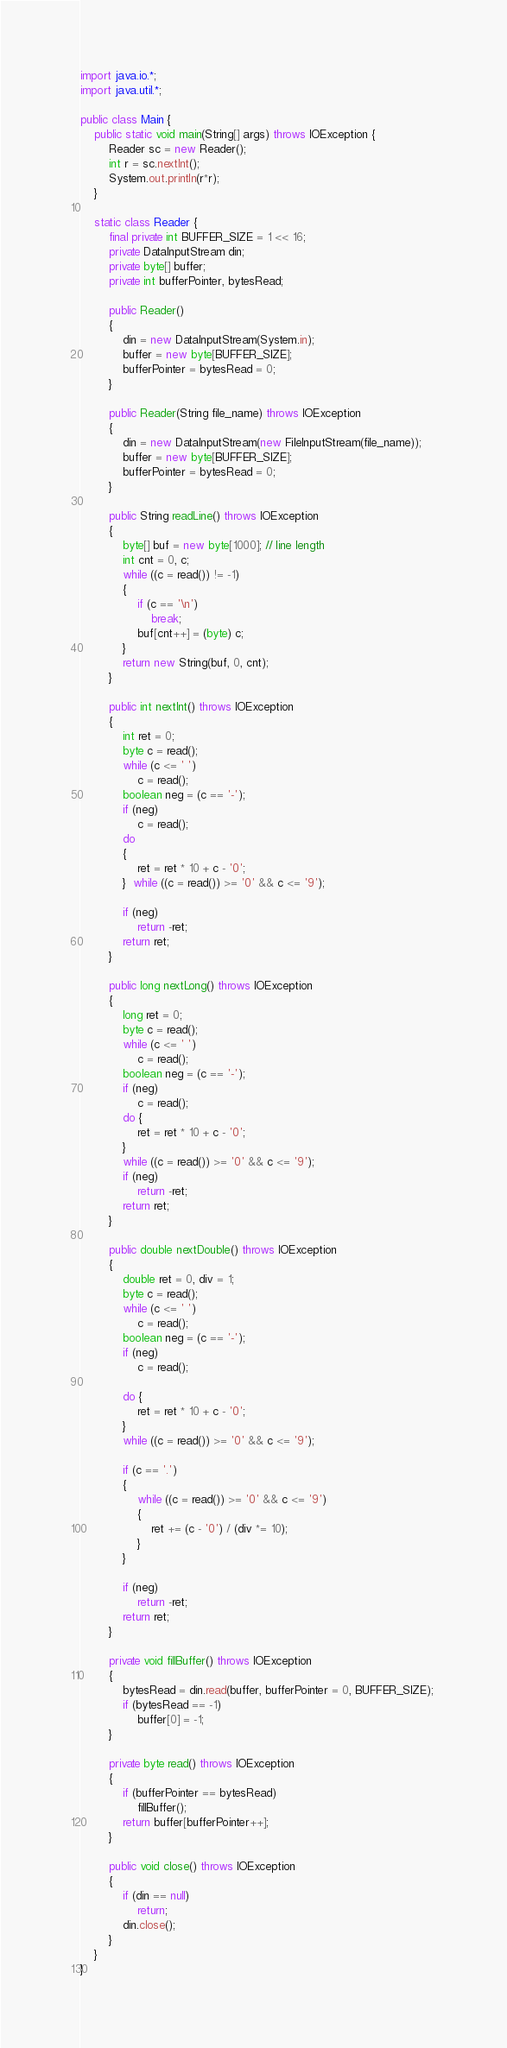Convert code to text. <code><loc_0><loc_0><loc_500><loc_500><_Java_>import java.io.*;
import java.util.*;

public class Main {
	public static void main(String[] args) throws IOException {
	    Reader sc = new Reader();
	    int r = sc.nextInt();
	   	System.out.println(r*r);
	}
	
	static class Reader { 
        final private int BUFFER_SIZE = 1 << 16; 
        private DataInputStream din; 
        private byte[] buffer; 
        private int bufferPointer, bytesRead; 
  
        public Reader() 
        { 
            din = new DataInputStream(System.in); 
            buffer = new byte[BUFFER_SIZE]; 
            bufferPointer = bytesRead = 0; 
        } 
  
        public Reader(String file_name) throws IOException 
        { 
            din = new DataInputStream(new FileInputStream(file_name)); 
            buffer = new byte[BUFFER_SIZE]; 
            bufferPointer = bytesRead = 0; 
        } 
  
        public String readLine() throws IOException 
        { 
            byte[] buf = new byte[1000]; // line length 
            int cnt = 0, c; 
            while ((c = read()) != -1) 
            { 
                if (c == '\n') 
                    break; 
                buf[cnt++] = (byte) c; 
            } 
            return new String(buf, 0, cnt); 
        } 
  
        public int nextInt() throws IOException 
        { 
            int ret = 0; 
            byte c = read(); 
            while (c <= ' ') 
                c = read(); 
            boolean neg = (c == '-'); 
            if (neg) 
                c = read(); 
            do
            { 
                ret = ret * 10 + c - '0'; 
            }  while ((c = read()) >= '0' && c <= '9'); 
  
            if (neg) 
                return -ret; 
            return ret; 
        } 
  
        public long nextLong() throws IOException 
        { 
            long ret = 0; 
            byte c = read(); 
            while (c <= ' ') 
                c = read(); 
            boolean neg = (c == '-'); 
            if (neg) 
                c = read(); 
            do { 
                ret = ret * 10 + c - '0'; 
            } 
            while ((c = read()) >= '0' && c <= '9'); 
            if (neg) 
                return -ret; 
            return ret; 
        } 
  
        public double nextDouble() throws IOException 
        { 
            double ret = 0, div = 1; 
            byte c = read(); 
            while (c <= ' ') 
                c = read(); 
            boolean neg = (c == '-'); 
            if (neg) 
                c = read(); 
  
            do { 
                ret = ret * 10 + c - '0'; 
            } 
            while ((c = read()) >= '0' && c <= '9'); 
  
            if (c == '.') 
            { 
                while ((c = read()) >= '0' && c <= '9') 
                { 
                    ret += (c - '0') / (div *= 10); 
                } 
            } 
  
            if (neg) 
                return -ret; 
            return ret; 
        } 
  
        private void fillBuffer() throws IOException 
        { 
            bytesRead = din.read(buffer, bufferPointer = 0, BUFFER_SIZE); 
            if (bytesRead == -1) 
                buffer[0] = -1; 
        } 
  
        private byte read() throws IOException 
        { 
            if (bufferPointer == bytesRead) 
                fillBuffer(); 
            return buffer[bufferPointer++]; 
        } 
  
        public void close() throws IOException 
        { 
            if (din == null) 
                return; 
            din.close(); 
        } 
    } 
}

</code> 